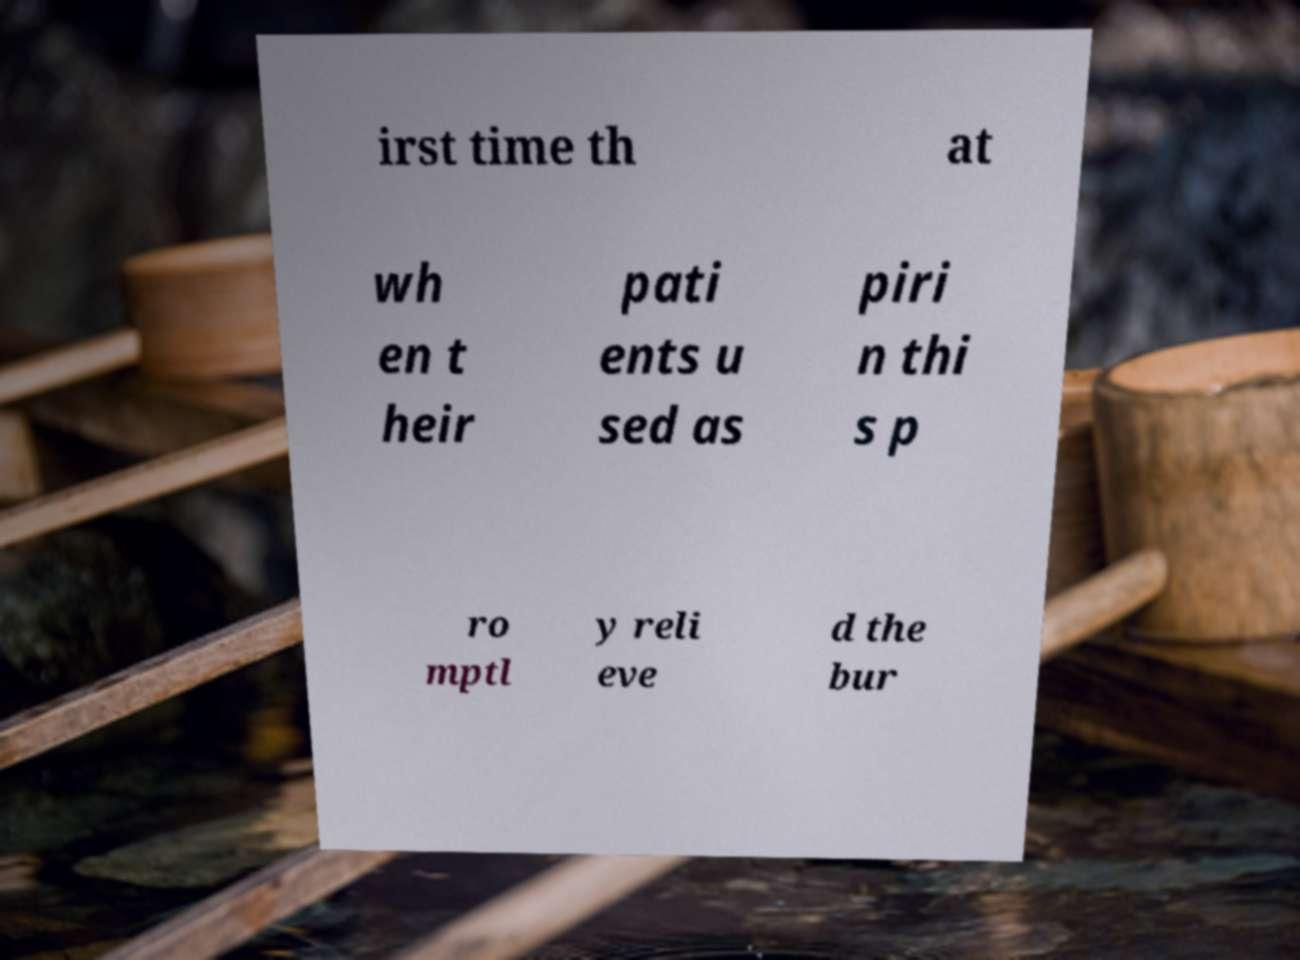Please identify and transcribe the text found in this image. irst time th at wh en t heir pati ents u sed as piri n thi s p ro mptl y reli eve d the bur 